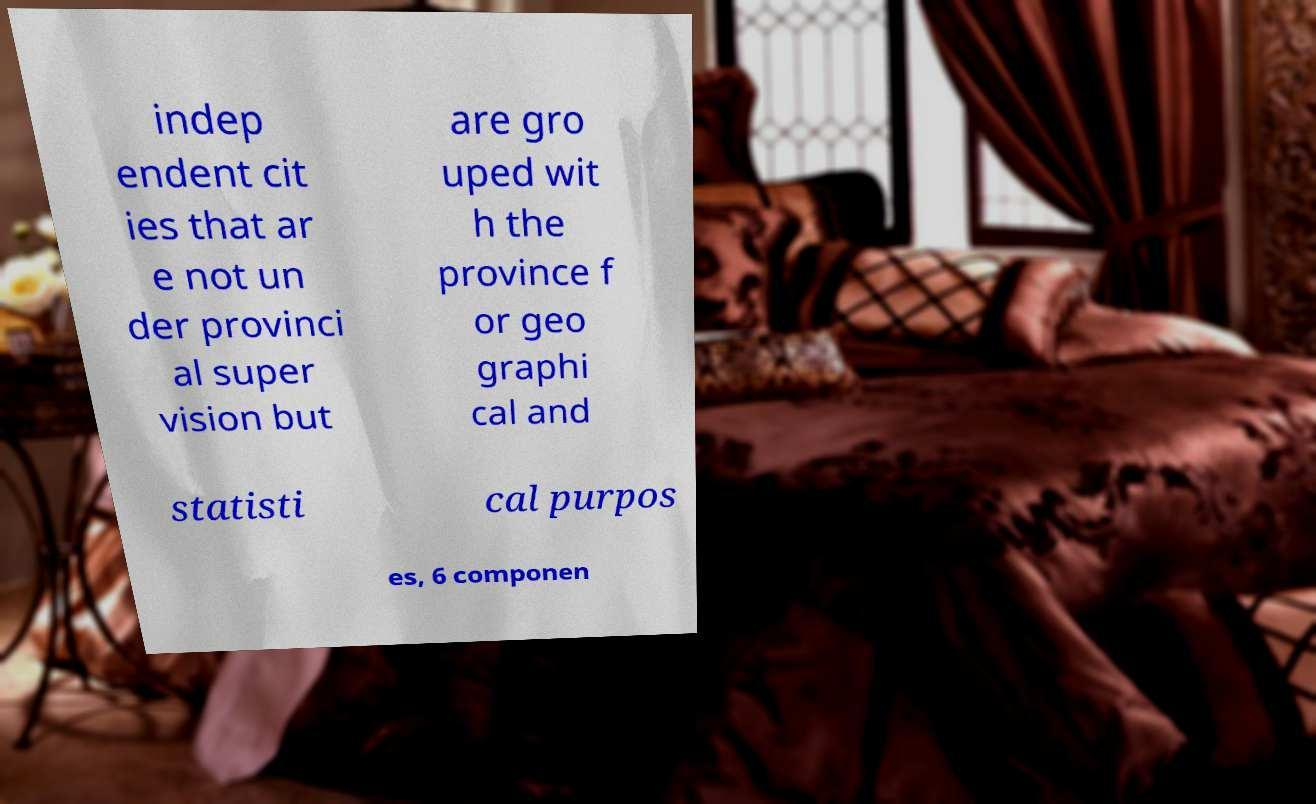Can you read and provide the text displayed in the image?This photo seems to have some interesting text. Can you extract and type it out for me? indep endent cit ies that ar e not un der provinci al super vision but are gro uped wit h the province f or geo graphi cal and statisti cal purpos es, 6 componen 